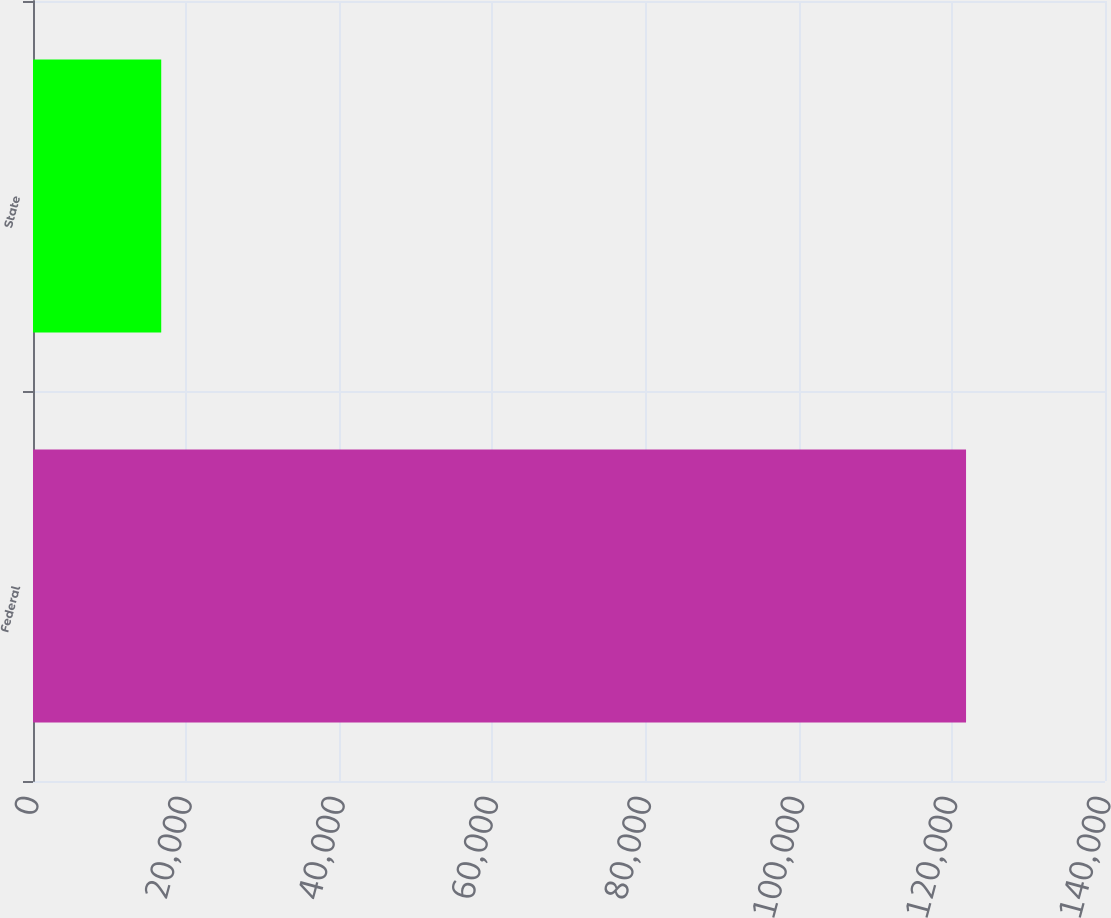Convert chart to OTSL. <chart><loc_0><loc_0><loc_500><loc_500><bar_chart><fcel>Federal<fcel>State<nl><fcel>121852<fcel>16745<nl></chart> 